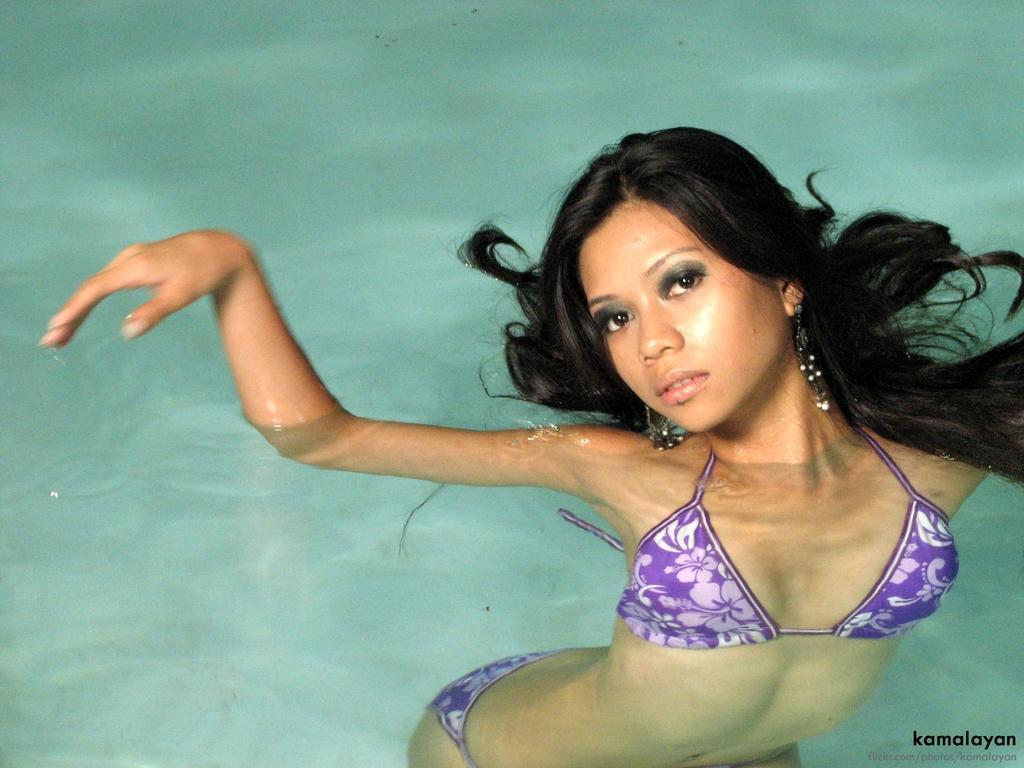Describe this image in one or two sentences. In this picture, we see a woman is swimming in the water and she is posing for the photo. In the background, we see water and this water might be in the swimming pool. 